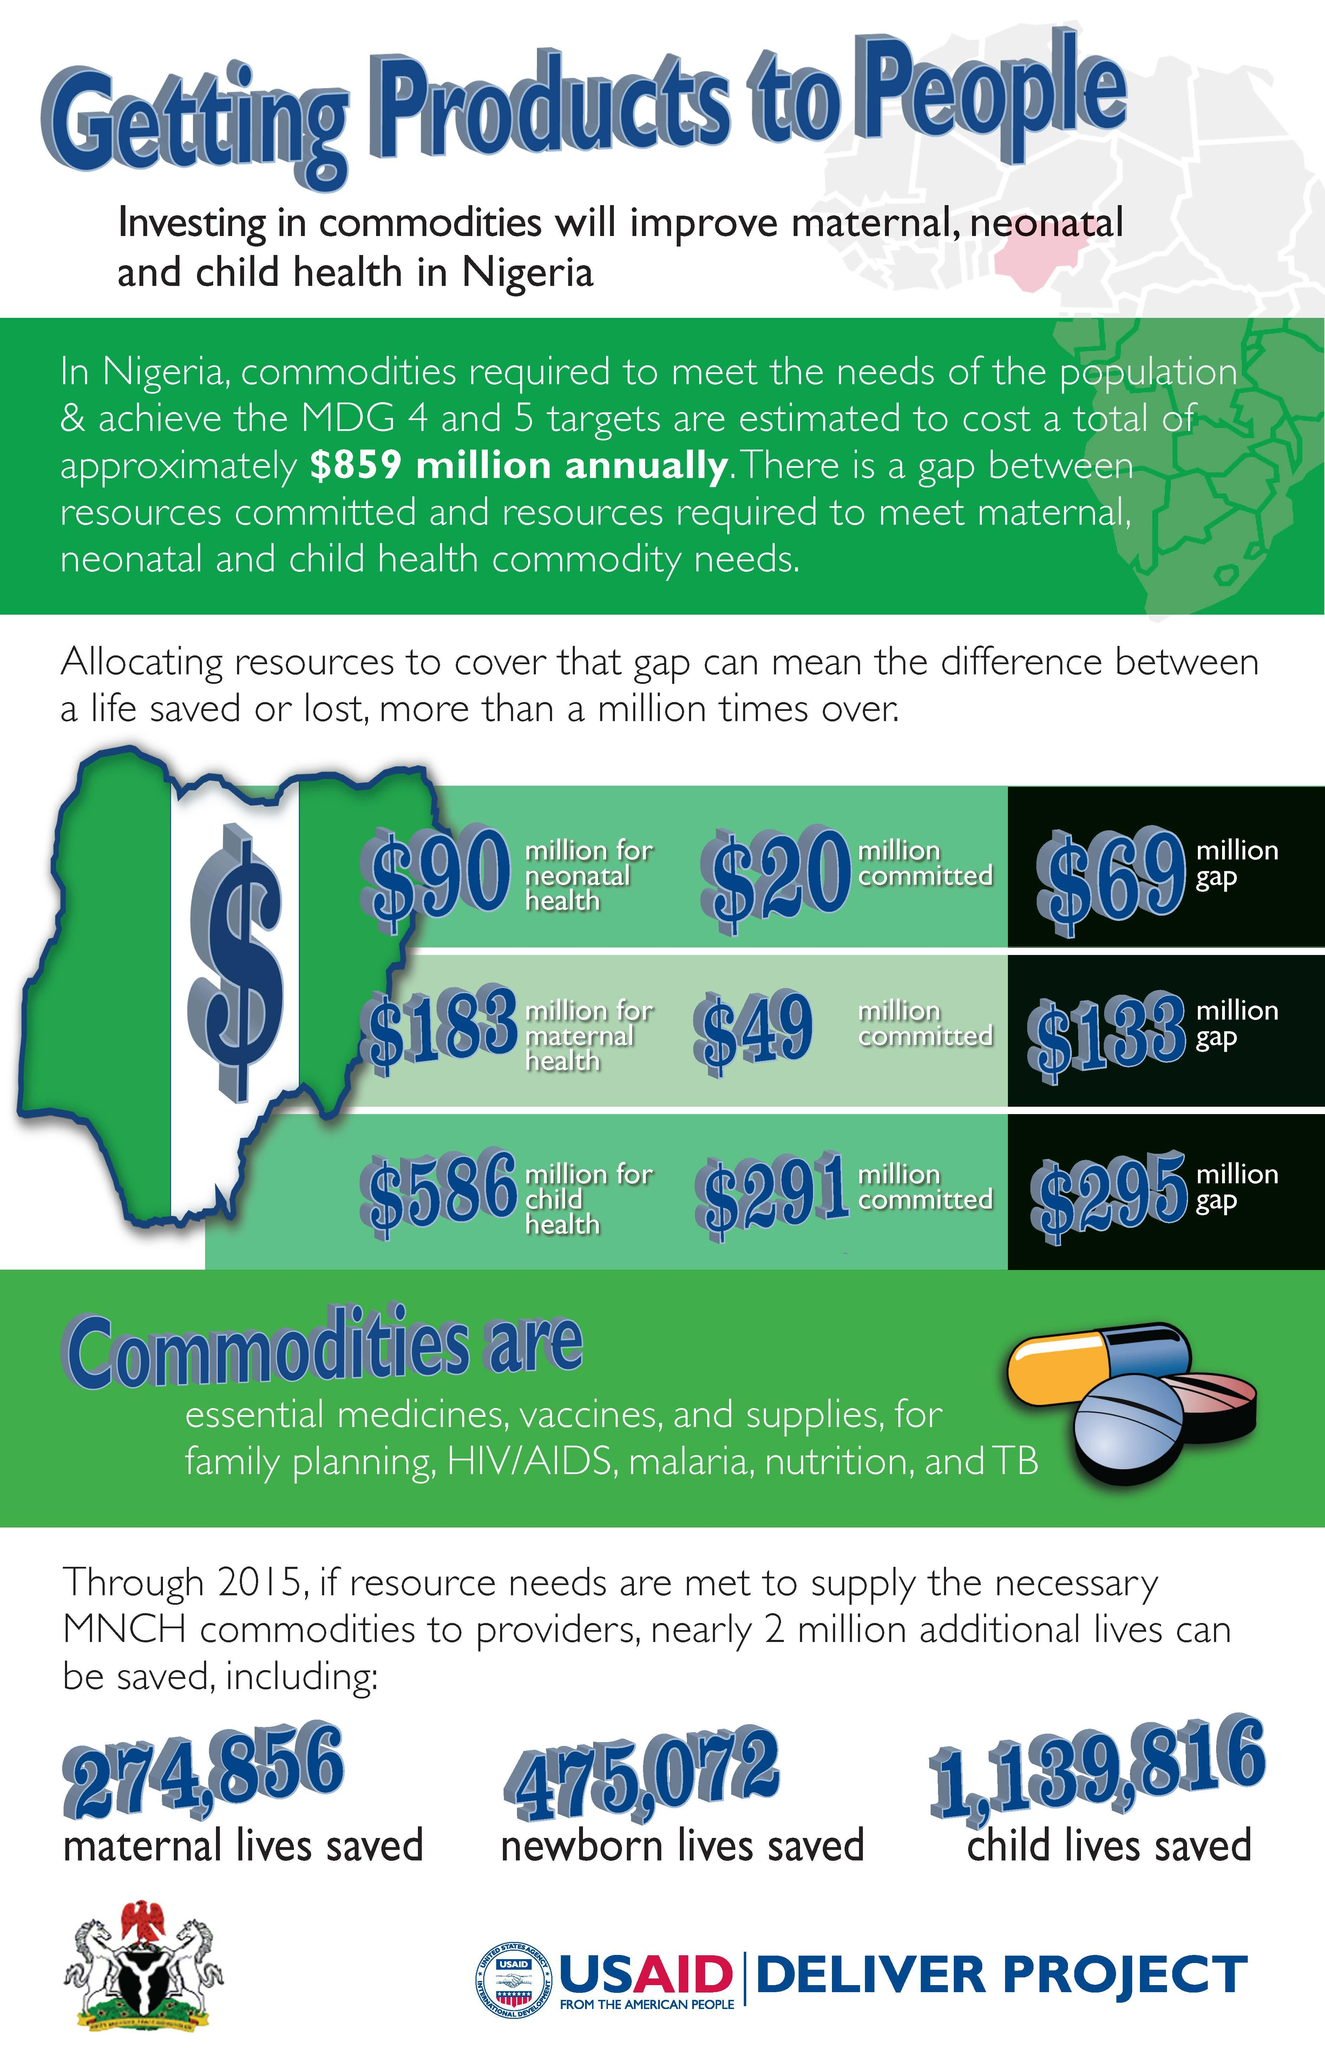Draw attention to some important aspects in this diagram. The total gap in achieving health commodity needs is $497 million. The total resources required for neonatal, maternal, and child health commodities are estimated to be $859 million. As of 2021, a total of $360 million has been committed towards neonatal, maternal, and child health commodities. 